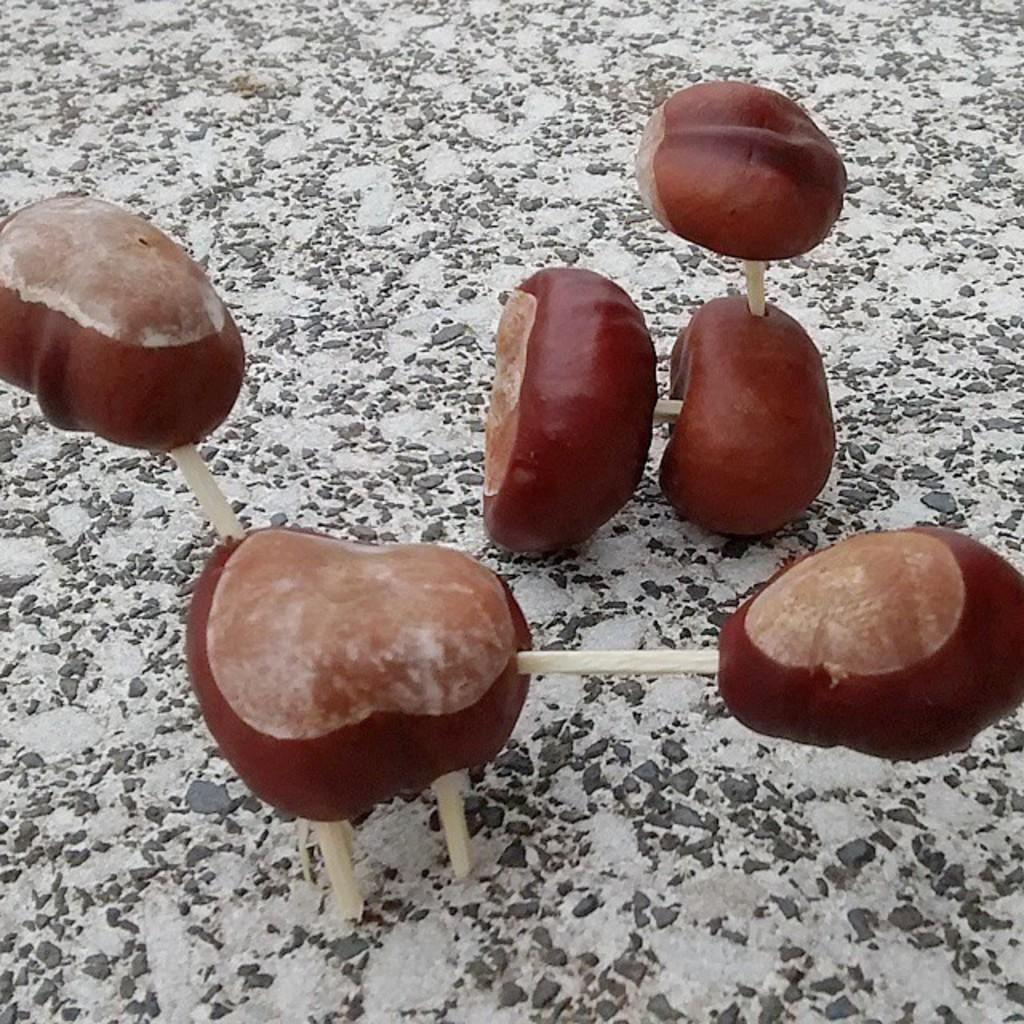What can be seen on the surface in the image? There are objects present on a surface in the image. Where is the rake stored in the image? There is no rake present in the image. What type of sponge is being used to clean the objects in the image? There is no sponge or cleaning activity depicted in the image. 